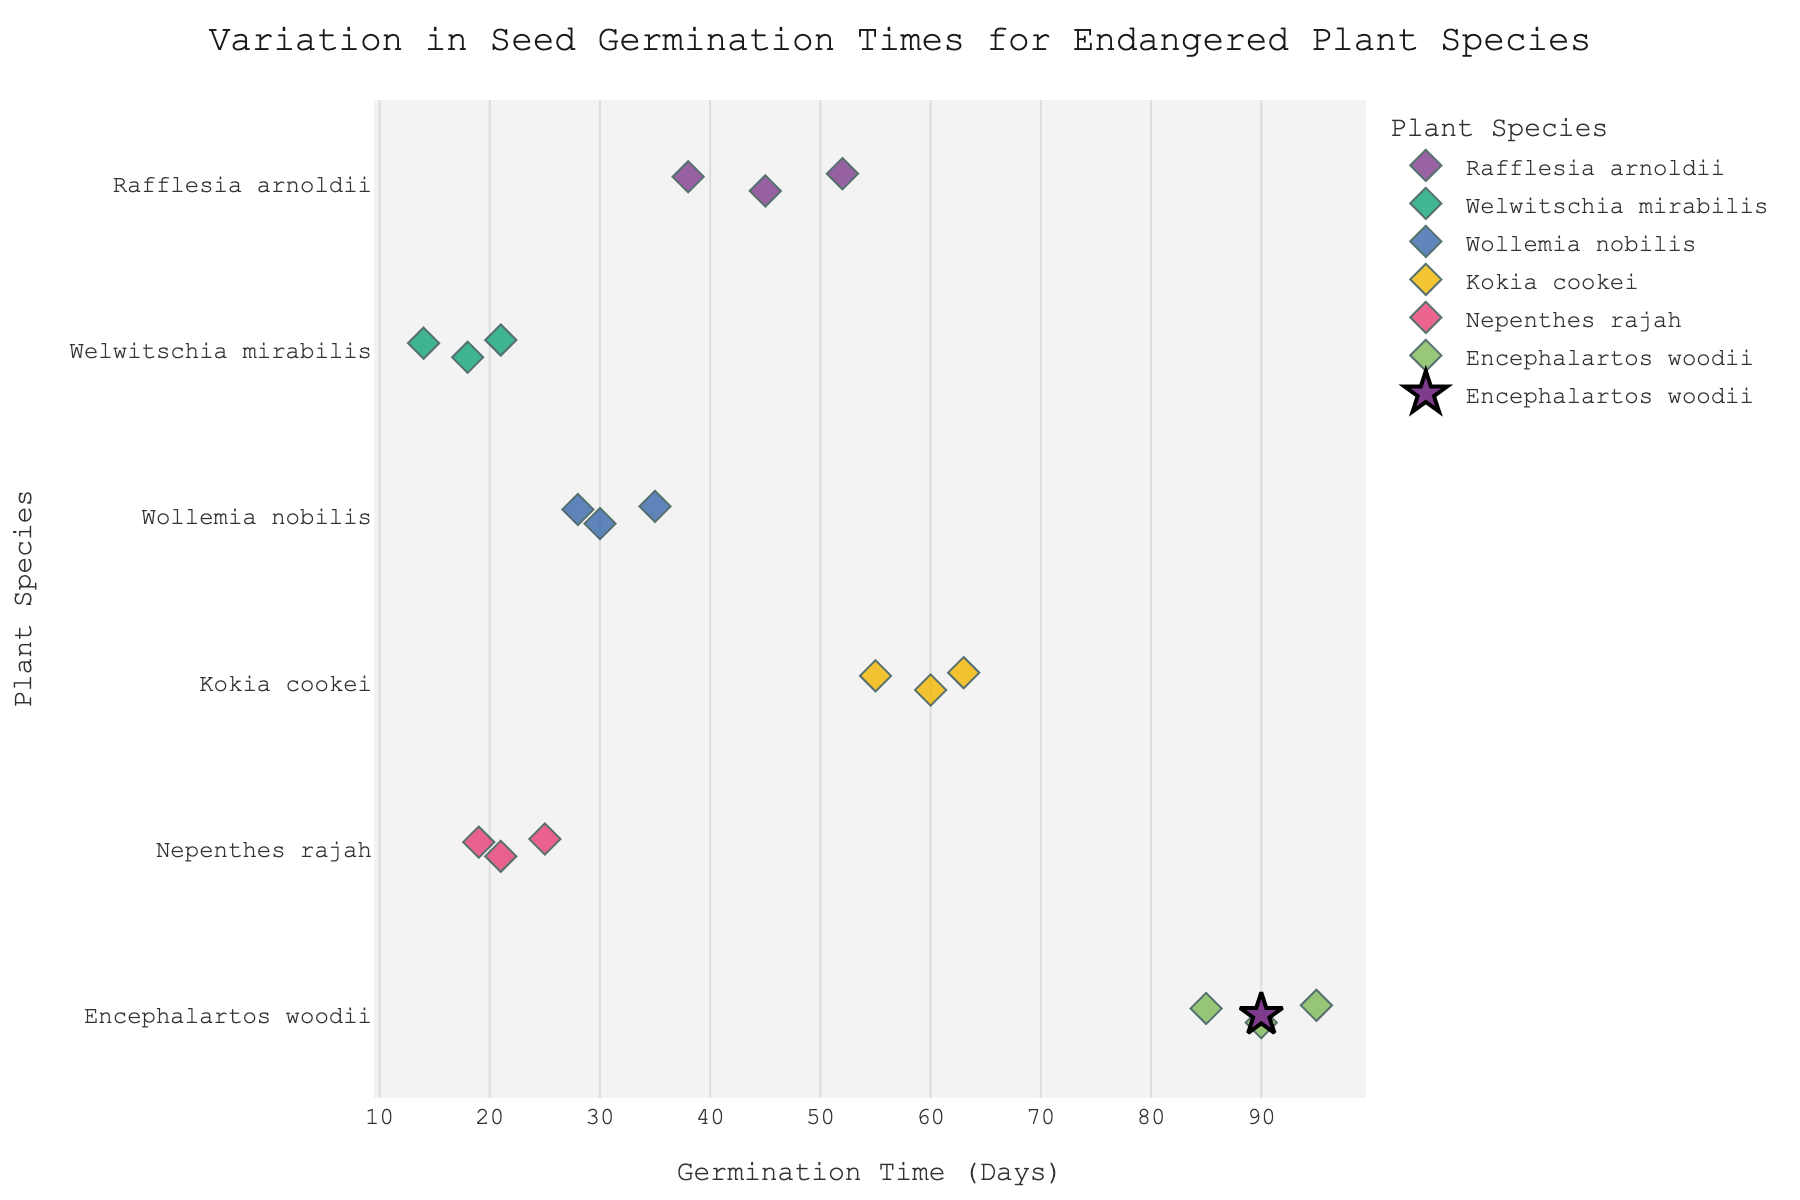How many plant species are represented in the plot? By counting the unique species on the y-axis, we can see how many different plant species are included in the plot.
Answer: 6 Which species has the longest germination time? By observing the x-axis, which shows germination times, and looking at the position of the dots on the right end, Encephalartos woodii stands out with germination times reaching up to 95 days.
Answer: Encephalartos woodii What is the average germination time for Rafflesia arnoldii? To find the average germination time, we look at the mean marker (star symbol) for Rafflesia arnoldii.
Answer: 45 days Which species has the most tightly clustered germination times? Examining the spread of the dots along the x-axis for each species, Welwitschia mirabilis has dots that are close to each other within the 14 to 21 days range.
Answer: Welwitschia mirabilis Which two species have the smallest range of germination times? By checking each species, Welwitschia mirabilis (14-21 days) and Wollemia nobilis (28-35 days) have the smallest range.
Answer: Welwitschia mirabilis and Wollemia nobilis What species have overlapping ranges of germination times? By visually checking where species’ germination times overlap on the x-axis, Nepenthes rajah and Welwitschia mirabilis both lie between 14 to 25 days.
Answer: Nepenthes rajah and Welwitschia mirabilis Which species have germination times above 50 days? By looking at points above the 50 days mark on the x-axis, Rafflesia arnoldii, Kokia cookei, and Encephalartos woodii have germination times exceeding 50 days.
Answer: Rafflesia arnoldii, Kokia cookei, and Encephalartos woodii For which species is the mean marker (star symbol) furthest from its data points? Observing the relative position of the star symbol and its data points for each species, Encephalartos woodii has its mean marker farther from the extremes compared to other species.
Answer: Encephalartos woodii Which species shows the greatest variability in germination times? Considering the scatter of the dots along the x-axis, Encephalartos woodii shows the greatest spread from 85 to 95 days.
Answer: Encephalartos woodii What is the combined average germination time of Welwitschia mirabilis and Wollemia nobilis? First, find the mean for each (Welwitschia mirabilis: 17.67 and Wollemia nobilis: 31), then average these means: (17.67 + 31) / 2 = 24.33.
Answer: 24.33 days 